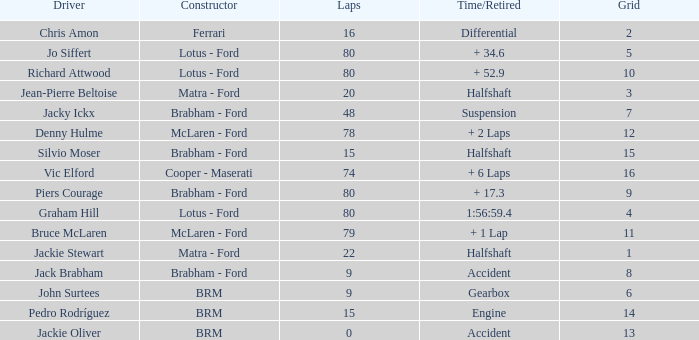What is the time/retired for brm with a grid of 13? Accident. 